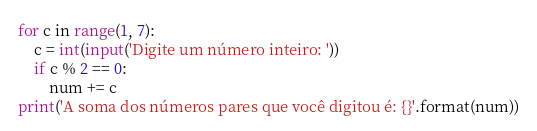<code> <loc_0><loc_0><loc_500><loc_500><_Python_>for c in range(1, 7):
    c = int(input('Digite um número inteiro: '))
    if c % 2 == 0:
        num += c
print('A soma dos números pares que você digitou é: {}'.format(num))
</code> 